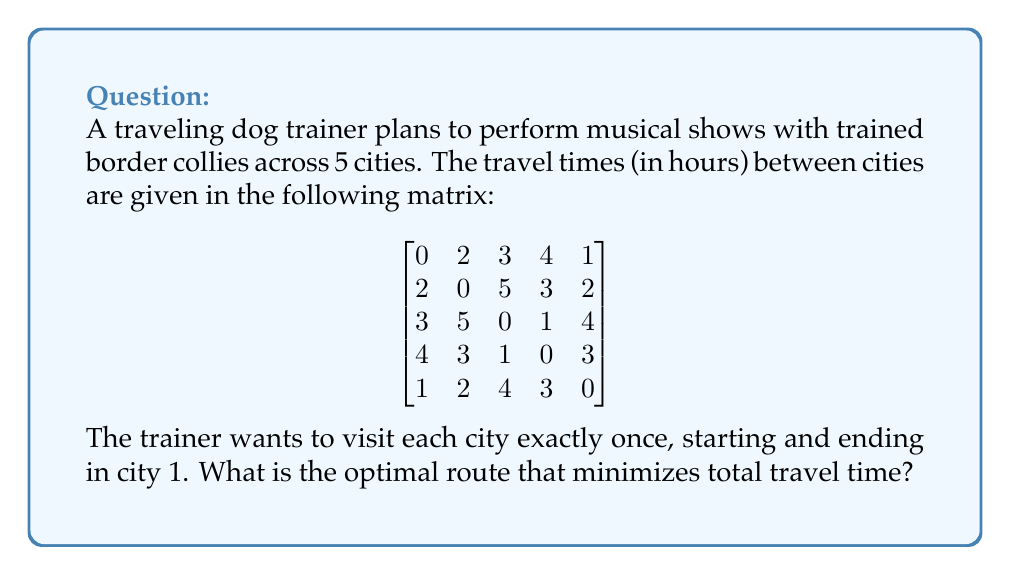Provide a solution to this math problem. This problem is a classic example of the Traveling Salesman Problem (TSP). To solve it, we can use the following steps:

1. Identify all possible routes:
   Since we start and end at city 1, we need to arrange the other 4 cities. This gives us 4! = 24 possible routes.

2. Calculate the total travel time for each route:
   For each route, sum the travel times between consecutive cities, including the return to city 1.

3. Compare all routes to find the minimum total travel time:

Let's examine a few routes:

Route 1-2-3-4-5-1:
$2 + 5 + 1 + 3 + 1 = 12$ hours

Route 1-2-4-3-5-1:
$2 + 3 + 1 + 4 + 1 = 11$ hours

Route 1-5-2-3-4-1:
$1 + 2 + 5 + 1 + 4 = 13$ hours

After calculating all 24 routes, we find that the optimal route is 1-5-2-4-3-1.

4. Verify the optimal route:
   1-5-2-4-3-1: $1 + 2 + 3 + 1 + 3 = 10$ hours

This is the minimum total travel time among all possible routes.
Answer: The optimal route is 1-5-2-4-3-1, with a total travel time of 10 hours. 